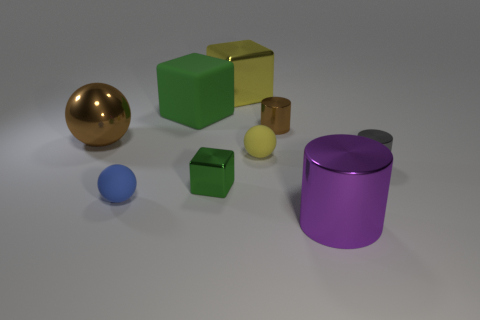What number of rubber objects are the same color as the large metal block?
Make the answer very short. 1. How many tiny things are purple cylinders or yellow metal cubes?
Ensure brevity in your answer.  0. Is there a brown object that has the same shape as the small yellow object?
Give a very brief answer. Yes. Is the shape of the green rubber thing the same as the large yellow metallic thing?
Keep it short and to the point. Yes. The metal block behind the green matte thing to the right of the small blue thing is what color?
Your answer should be very brief. Yellow. What is the color of the metal ball that is the same size as the yellow metal cube?
Make the answer very short. Brown. How many matte objects are either purple things or tiny red cylinders?
Give a very brief answer. 0. How many small blue balls are behind the small shiny object on the right side of the purple metallic cylinder?
Ensure brevity in your answer.  0. There is a object that is the same color as the small metal cube; what size is it?
Your answer should be very brief. Large. How many objects are gray metallic objects or big things to the right of the tiny blue thing?
Offer a terse response. 4. 